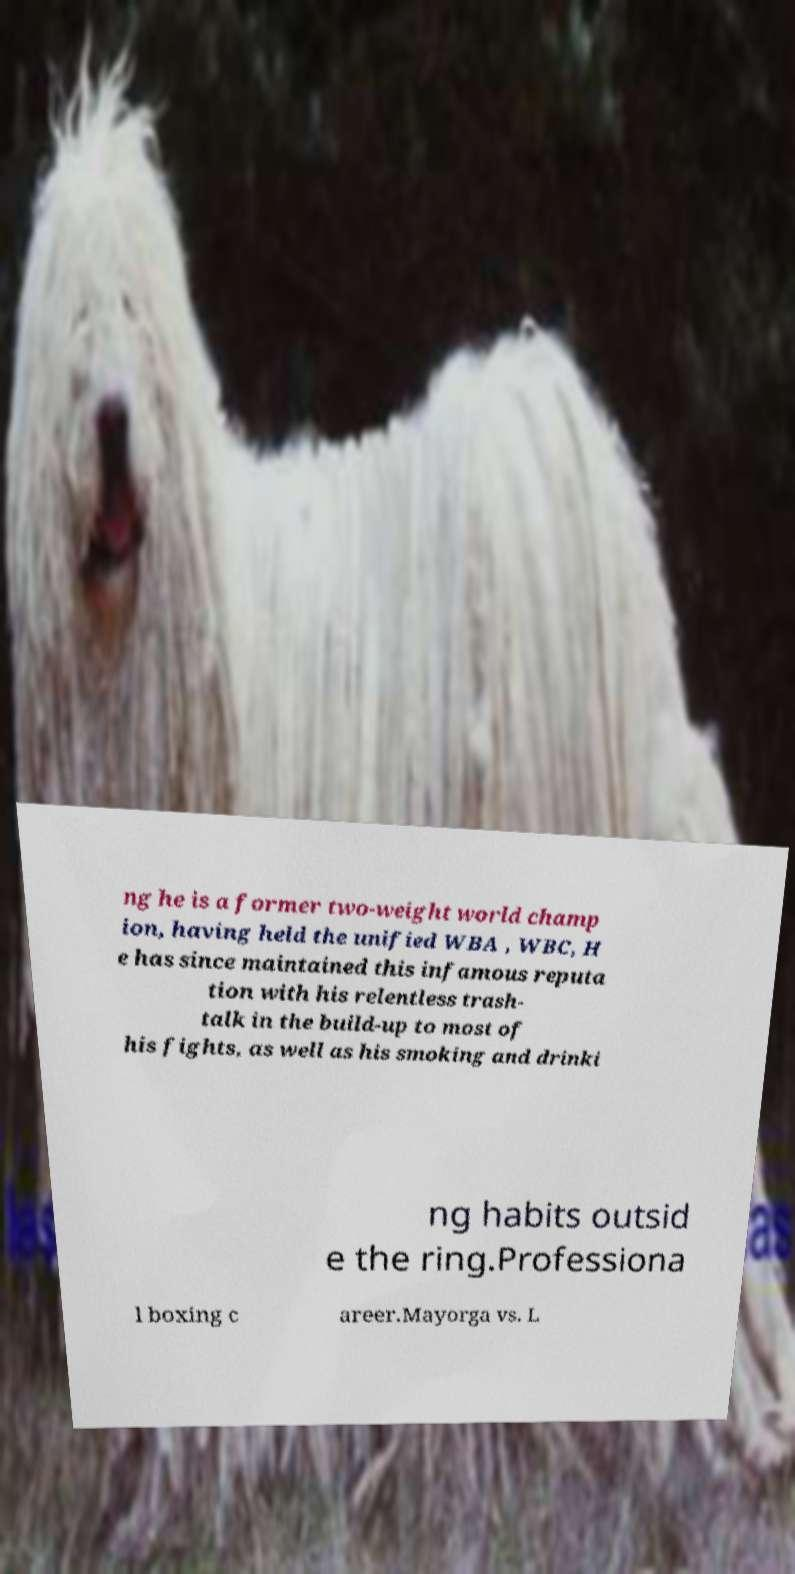For documentation purposes, I need the text within this image transcribed. Could you provide that? ng he is a former two-weight world champ ion, having held the unified WBA , WBC, H e has since maintained this infamous reputa tion with his relentless trash- talk in the build-up to most of his fights, as well as his smoking and drinki ng habits outsid e the ring.Professiona l boxing c areer.Mayorga vs. L 